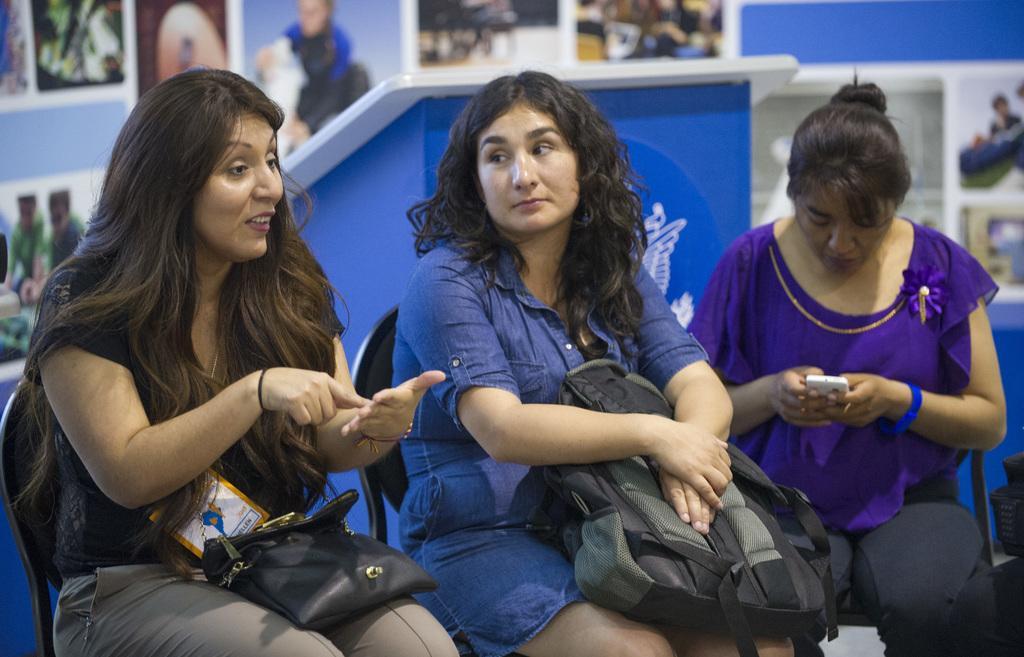Describe this image in one or two sentences. In this image, we can see people sitting on the chairs and on the right, there is a lady holding a mobile and on the left, we can see a person wearing a bag and there is a card and the middle person is holding a bag. In the background, there are frames on the wall and we can see a stand and some other objects. 